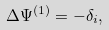<formula> <loc_0><loc_0><loc_500><loc_500>\Delta \Psi ^ { ( 1 ) } = - \delta _ { i } ,</formula> 